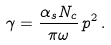Convert formula to latex. <formula><loc_0><loc_0><loc_500><loc_500>\gamma = \frac { \alpha _ { s } N _ { c } } { \pi \omega } \, p ^ { 2 } \, .</formula> 